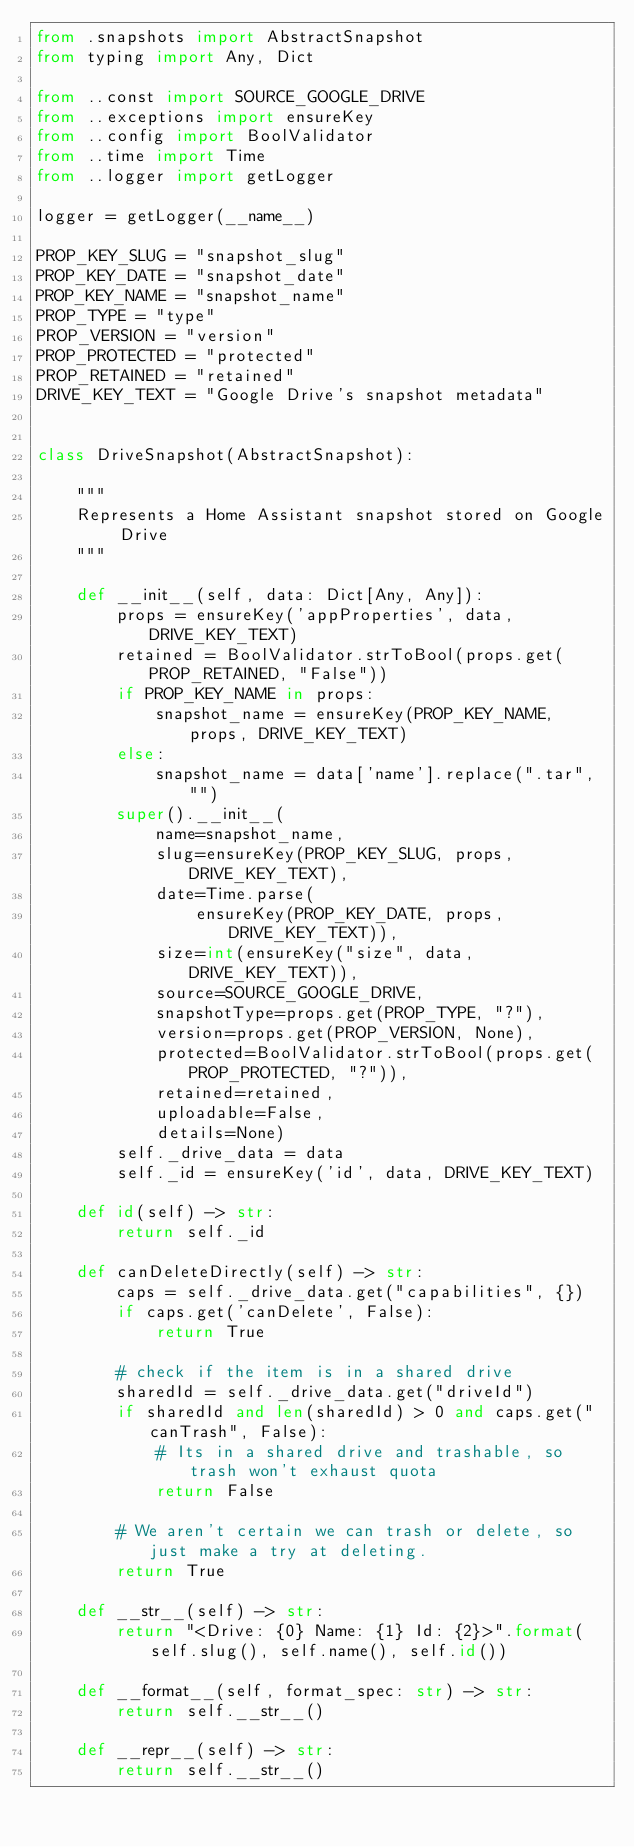Convert code to text. <code><loc_0><loc_0><loc_500><loc_500><_Python_>from .snapshots import AbstractSnapshot
from typing import Any, Dict

from ..const import SOURCE_GOOGLE_DRIVE
from ..exceptions import ensureKey
from ..config import BoolValidator
from ..time import Time
from ..logger import getLogger

logger = getLogger(__name__)

PROP_KEY_SLUG = "snapshot_slug"
PROP_KEY_DATE = "snapshot_date"
PROP_KEY_NAME = "snapshot_name"
PROP_TYPE = "type"
PROP_VERSION = "version"
PROP_PROTECTED = "protected"
PROP_RETAINED = "retained"
DRIVE_KEY_TEXT = "Google Drive's snapshot metadata"


class DriveSnapshot(AbstractSnapshot):

    """
    Represents a Home Assistant snapshot stored on Google Drive
    """

    def __init__(self, data: Dict[Any, Any]):
        props = ensureKey('appProperties', data, DRIVE_KEY_TEXT)
        retained = BoolValidator.strToBool(props.get(PROP_RETAINED, "False"))
        if PROP_KEY_NAME in props:
            snapshot_name = ensureKey(PROP_KEY_NAME, props, DRIVE_KEY_TEXT)
        else:
            snapshot_name = data['name'].replace(".tar", "")
        super().__init__(
            name=snapshot_name,
            slug=ensureKey(PROP_KEY_SLUG, props, DRIVE_KEY_TEXT),
            date=Time.parse(
                ensureKey(PROP_KEY_DATE, props, DRIVE_KEY_TEXT)),
            size=int(ensureKey("size", data, DRIVE_KEY_TEXT)),
            source=SOURCE_GOOGLE_DRIVE,
            snapshotType=props.get(PROP_TYPE, "?"),
            version=props.get(PROP_VERSION, None),
            protected=BoolValidator.strToBool(props.get(PROP_PROTECTED, "?")),
            retained=retained,
            uploadable=False,
            details=None)
        self._drive_data = data
        self._id = ensureKey('id', data, DRIVE_KEY_TEXT)

    def id(self) -> str:
        return self._id

    def canDeleteDirectly(self) -> str:
        caps = self._drive_data.get("capabilities", {})
        if caps.get('canDelete', False):
            return True

        # check if the item is in a shared drive
        sharedId = self._drive_data.get("driveId")
        if sharedId and len(sharedId) > 0 and caps.get("canTrash", False):
            # Its in a shared drive and trashable, so trash won't exhaust quota
            return False

        # We aren't certain we can trash or delete, so just make a try at deleting.
        return True

    def __str__(self) -> str:
        return "<Drive: {0} Name: {1} Id: {2}>".format(self.slug(), self.name(), self.id())

    def __format__(self, format_spec: str) -> str:
        return self.__str__()

    def __repr__(self) -> str:
        return self.__str__()
</code> 